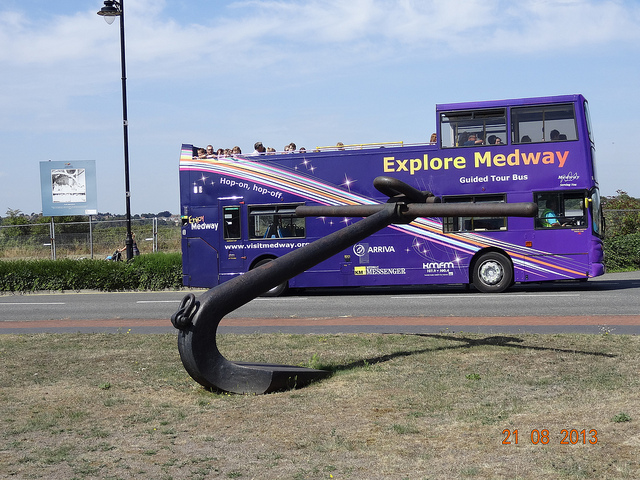Please transcribe the text in this image. Medway Explore Medway Gulded TOUR BUS 2013 08 21 KM Hmfm MESSENGER ARRMA www.visitmedway.com -OH hop on HOP 